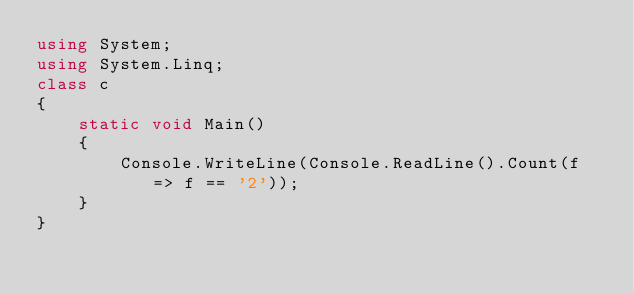<code> <loc_0><loc_0><loc_500><loc_500><_C++_>using System;
using System.Linq;
class c
{
    static void Main()
    {
        Console.WriteLine(Console.ReadLine().Count(f => f == '2'));
    }
}</code> 